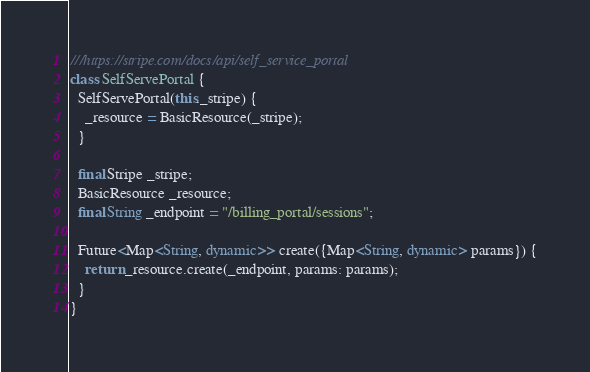<code> <loc_0><loc_0><loc_500><loc_500><_Dart_>///https://stripe.com/docs/api/self_service_portal
class SelfServePortal {
  SelfServePortal(this._stripe) {
    _resource = BasicResource(_stripe);
  }

  final Stripe _stripe;
  BasicResource _resource;
  final String _endpoint = "/billing_portal/sessions";

  Future<Map<String, dynamic>> create({Map<String, dynamic> params}) {
    return _resource.create(_endpoint, params: params);
  }
}
</code> 